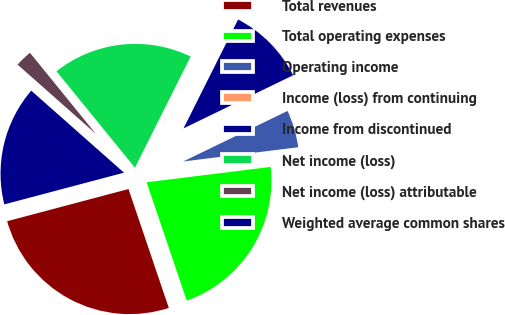Convert chart to OTSL. <chart><loc_0><loc_0><loc_500><loc_500><pie_chart><fcel>Total revenues<fcel>Total operating expenses<fcel>Operating income<fcel>Income (loss) from continuing<fcel>Income from discontinued<fcel>Net income (loss)<fcel>Net income (loss) attributable<fcel>Weighted average common shares<nl><fcel>26.08%<fcel>21.76%<fcel>5.22%<fcel>0.0%<fcel>10.43%<fcel>18.26%<fcel>2.61%<fcel>15.65%<nl></chart> 